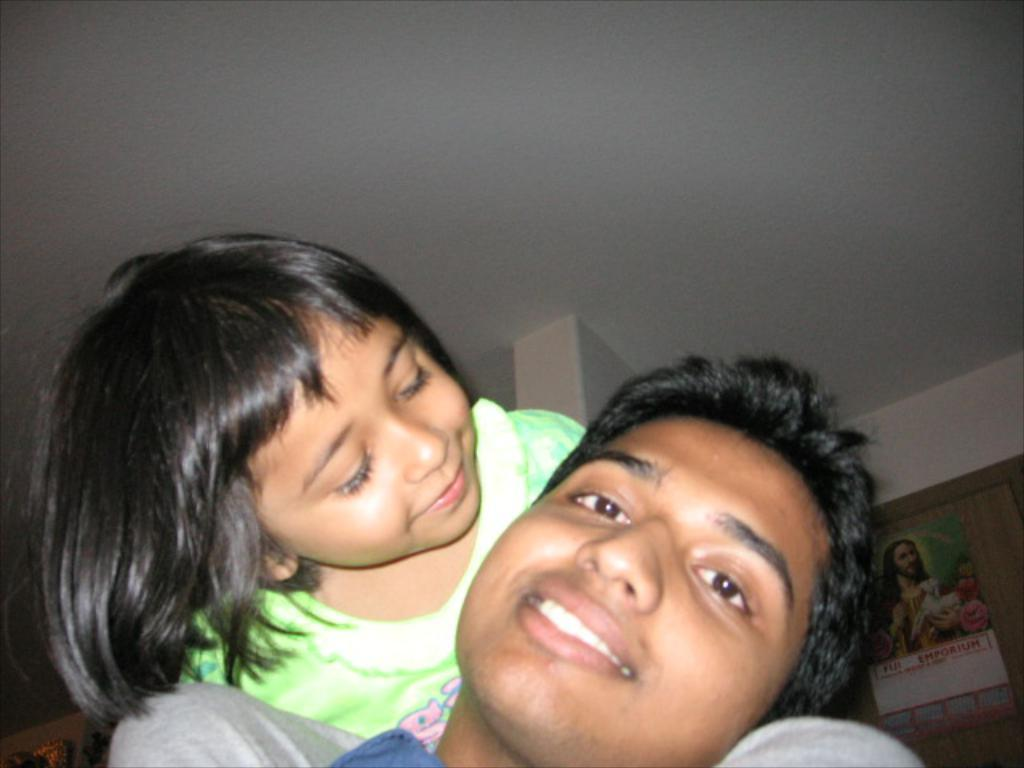What is the main subject of the image? The main subject of the image is a kid. What can be observed about the kid's attire? The kid is wearing clothes. Who is the kid looking at in the image? The kid is looking at a person. What object can be seen in the bottom right corner of the image? There is a calendar in the bottom right corner of the image. What part of the room is visible at the top of the image? There is a ceiling visible at the top of the image. What type of food is the kid eating in the image? There is no food visible in the image, so it cannot be determined what the kid might be eating. 